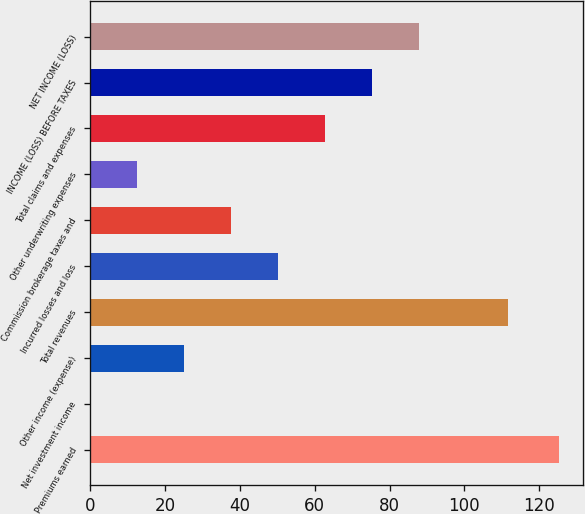Convert chart. <chart><loc_0><loc_0><loc_500><loc_500><bar_chart><fcel>Premiums earned<fcel>Net investment income<fcel>Other income (expense)<fcel>Total revenues<fcel>Incurred losses and loss<fcel>Commission brokerage taxes and<fcel>Other underwriting expenses<fcel>Total claims and expenses<fcel>INCOME (LOSS) BEFORE TAXES<fcel>NET INCOME (LOSS)<nl><fcel>125.4<fcel>0.1<fcel>25.16<fcel>111.6<fcel>50.22<fcel>37.69<fcel>12.63<fcel>62.75<fcel>75.28<fcel>87.81<nl></chart> 